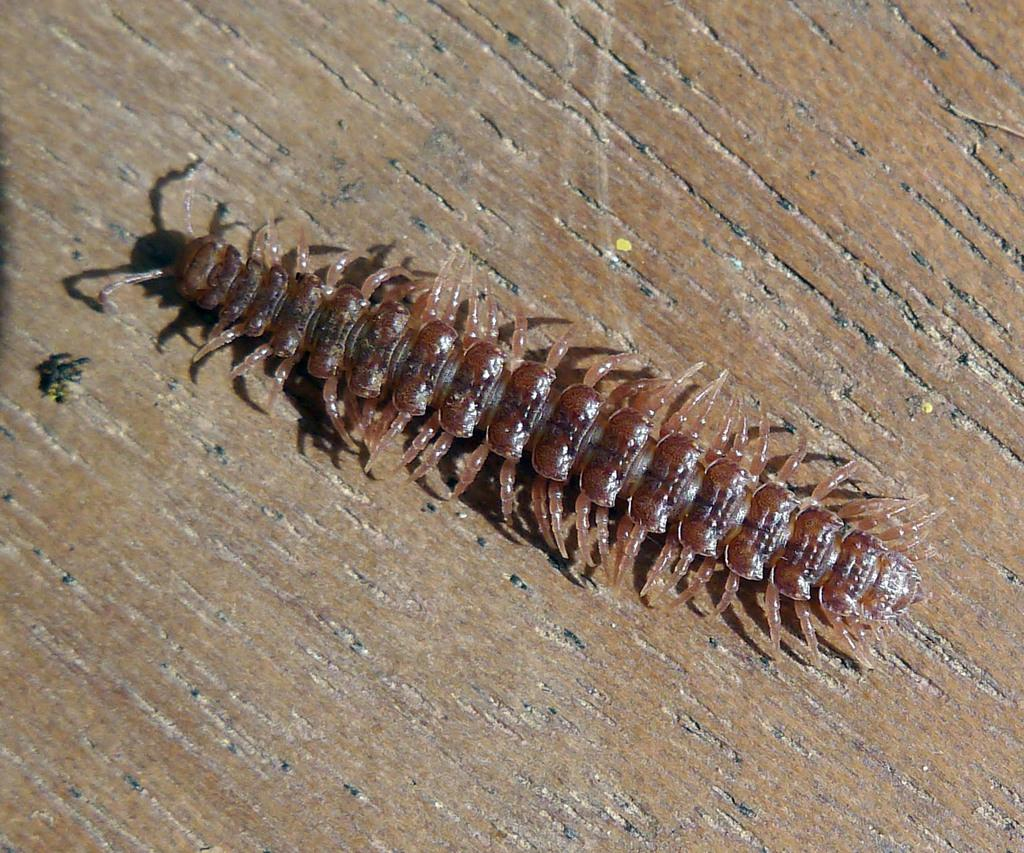What type of creature can be seen in the image? There is an insect in the image. What is the insect resting on in the image? The insect is on a wooden surface. How much money is the insect holding in the image? There is no money present in the image, and insects do not have the ability to hold or carry money. 